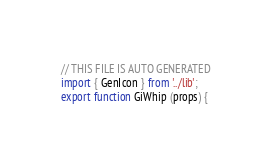<code> <loc_0><loc_0><loc_500><loc_500><_JavaScript_>// THIS FILE IS AUTO GENERATED
import { GenIcon } from '../lib';
export function GiWhip (props) {</code> 